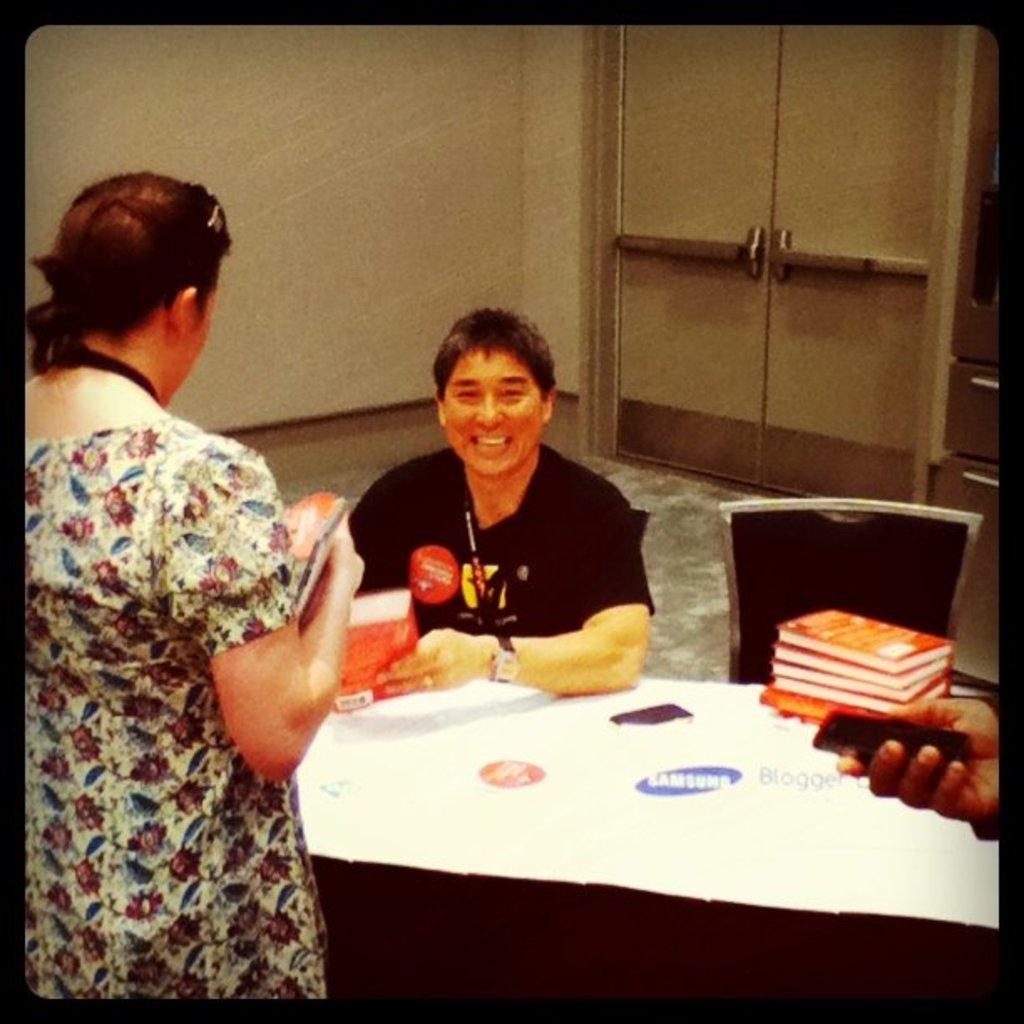How would you summarize this image in a sentence or two? In this image I can see three people. I can see one person sitting in-front of the table. On the table I can see the books and few objects. To the side I can see the one more chair and the person holding the black color object. In the background I can see the wall and the door. 